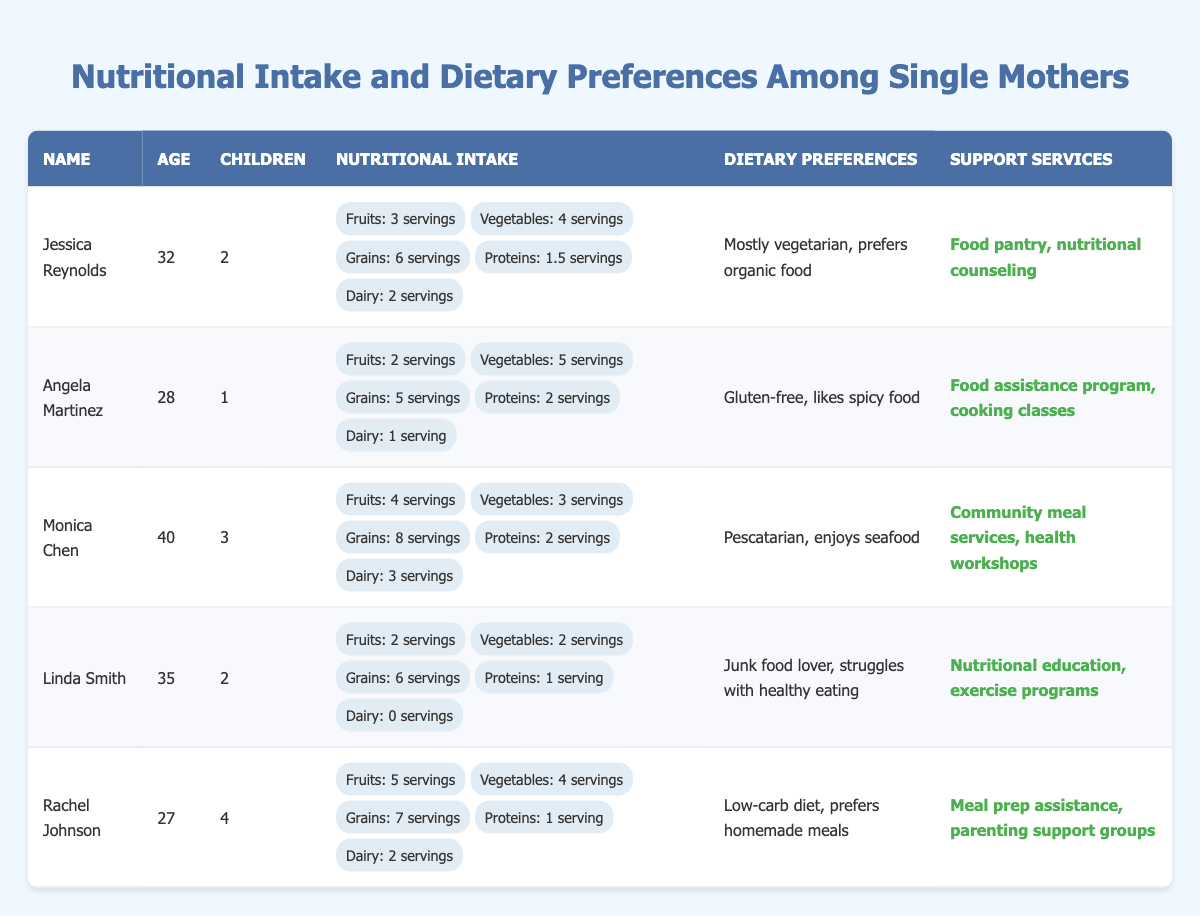What is the age of Rachel Johnson? From the table, we can see the entry for Rachel Johnson. Her age is listed directly under her name.
Answer: 27 How many servings of dairy does Jessica Reynolds consume? The table shows that in the nutritional intake for Jessica Reynolds, the dairy consumption is specified as 2 servings.
Answer: 2 servings Who has the highest nutritional intake of fruits? By comparing the servings of fruits across all entries in the table, Monica Chen has the highest intake at 4 servings.
Answer: Monica Chen How many total children do the single mothers have combined? The total number of children can be obtained by adding the children from all entries: 2 + 1 + 3 + 2 + 4 = 12.
Answer: 12 Does Linda Smith prefer healthy eating? Linda Smith's dietary preferences indicate that she is a junk food lover and struggles with healthy eating, suggesting she does not prefer healthy eating.
Answer: No Which single mother has the highest intake of grains? Examining the nutritional intake, Monica Chen has the highest grain intake at 8 servings compared to others.
Answer: Monica Chen What is the combined protein intake of Jessica Reynolds and Angela Martinez? The protein intakes are 1.5 servings for Jessica Reynolds and 2 servings for Angela Martinez. Adding them together gives 1.5 + 2 = 3.5 servings.
Answer: 3.5 servings Which dietary preference is listed by Rachel Johnson? The table shows Rachel Johnson's dietary preference is a low-carb diet and she prefers homemade meals.
Answer: Low-carb diet, prefers homemade meals How many servings of vegetables does Angela Martinez consume? Angela Martinez's nutritional intake shows that she consumes 5 servings of vegetables, as noted in the table.
Answer: 5 servings Is Monica Chen a vegetarian? Monica Chen's dietary preferences specify that she is pescatarian and enjoys seafood, which means she is not a purely vegetarian.
Answer: No 